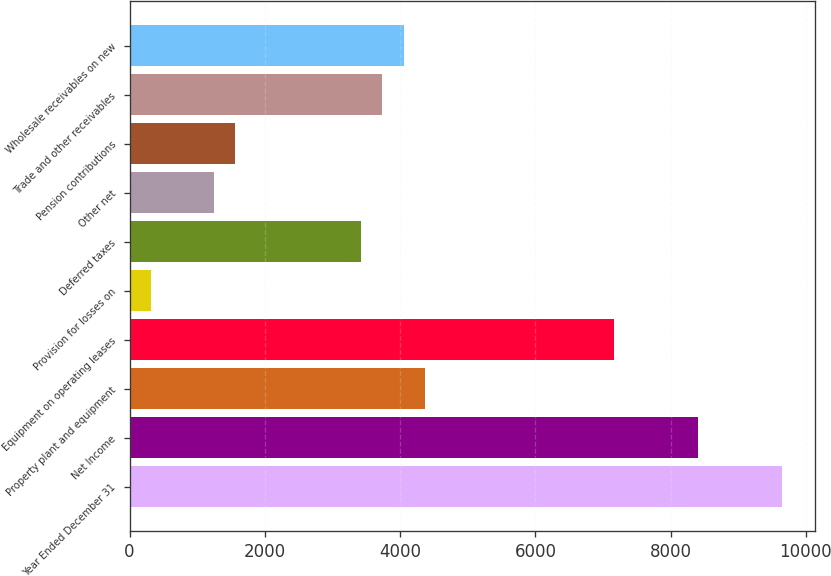Convert chart. <chart><loc_0><loc_0><loc_500><loc_500><bar_chart><fcel>Year Ended December 31<fcel>Net Income<fcel>Property plant and equipment<fcel>Equipment on operating leases<fcel>Provision for losses on<fcel>Deferred taxes<fcel>Other net<fcel>Pension contributions<fcel>Trade and other receivables<fcel>Wholesale receivables on new<nl><fcel>9651.16<fcel>8406.52<fcel>4361.44<fcel>7161.88<fcel>316.36<fcel>3427.96<fcel>1249.84<fcel>1561<fcel>3739.12<fcel>4050.28<nl></chart> 